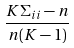Convert formula to latex. <formula><loc_0><loc_0><loc_500><loc_500>\frac { K \Sigma _ { i i } - n } { n ( K - 1 ) }</formula> 